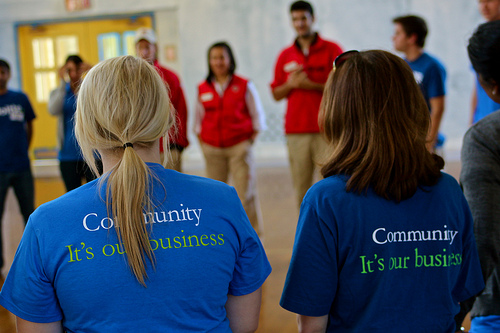<image>
Is the girl next to the door? No. The girl is not positioned next to the door. They are located in different areas of the scene. 